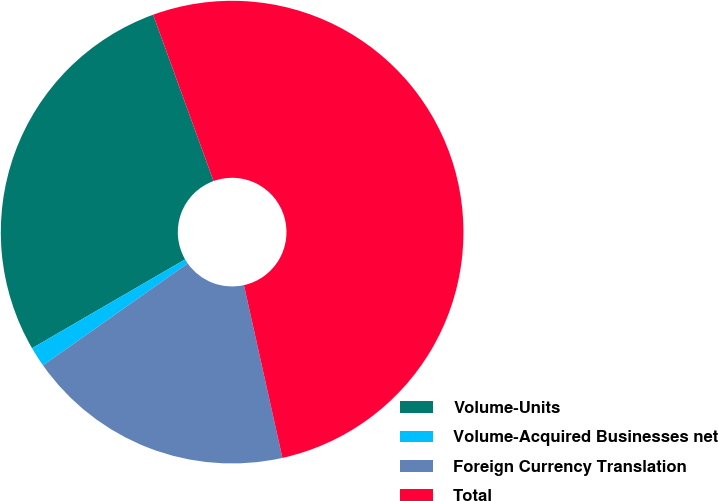Convert chart. <chart><loc_0><loc_0><loc_500><loc_500><pie_chart><fcel>Volume-Units<fcel>Volume-Acquired Businesses net<fcel>Foreign Currency Translation<fcel>Total<nl><fcel>27.82%<fcel>1.4%<fcel>18.72%<fcel>52.06%<nl></chart> 